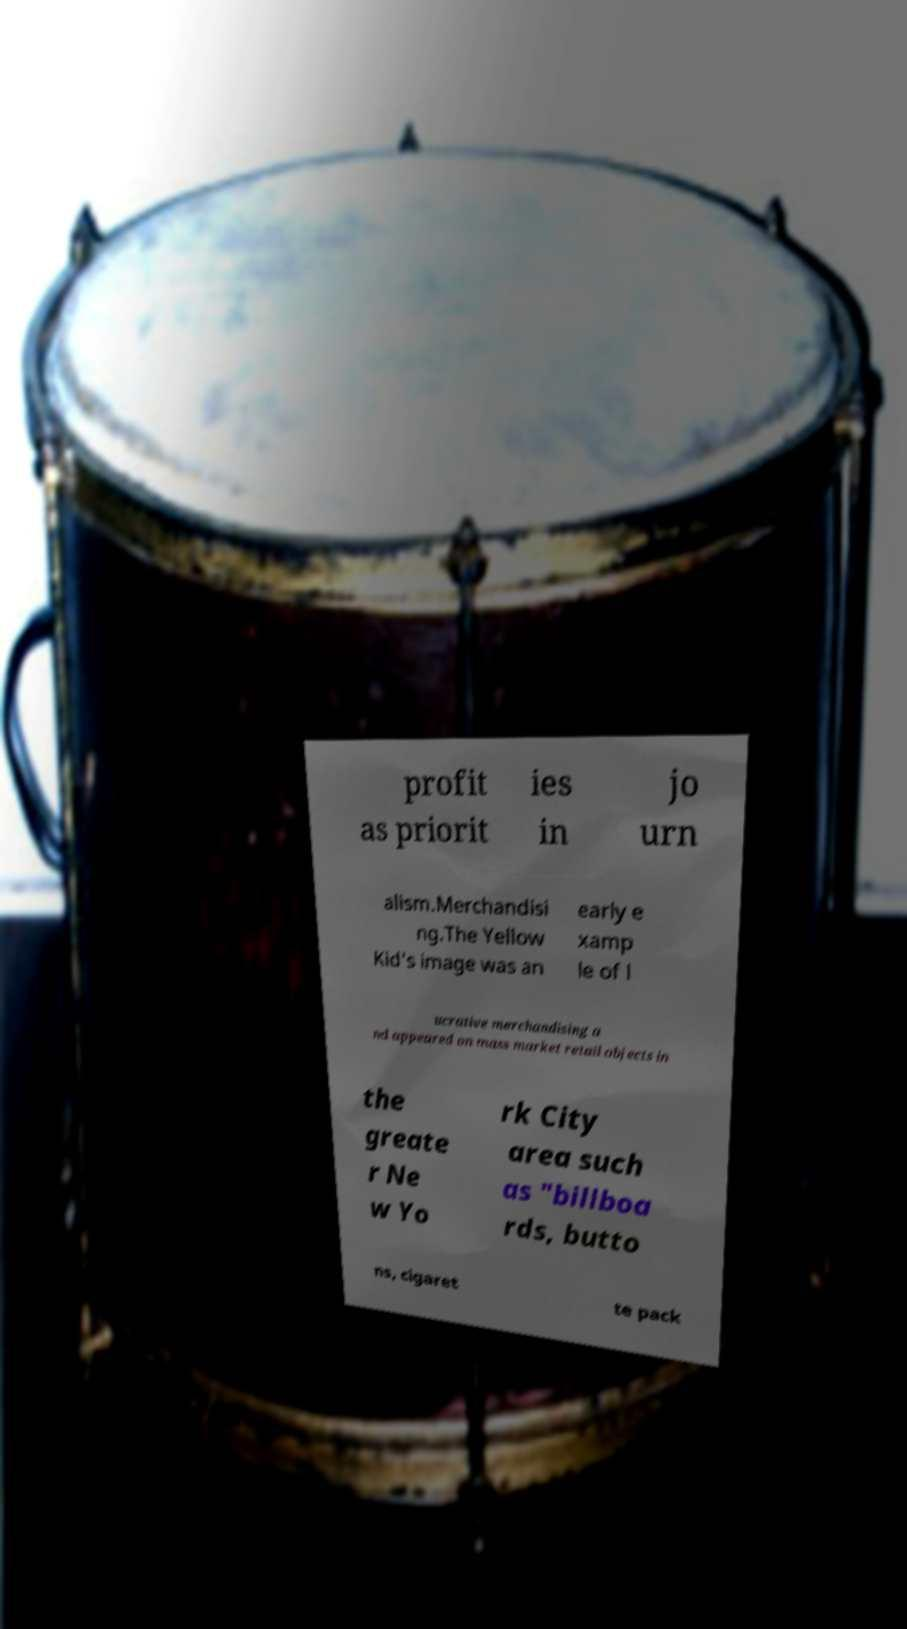I need the written content from this picture converted into text. Can you do that? profit as priorit ies in jo urn alism.Merchandisi ng.The Yellow Kid's image was an early e xamp le of l ucrative merchandising a nd appeared on mass market retail objects in the greate r Ne w Yo rk City area such as "billboa rds, butto ns, cigaret te pack 